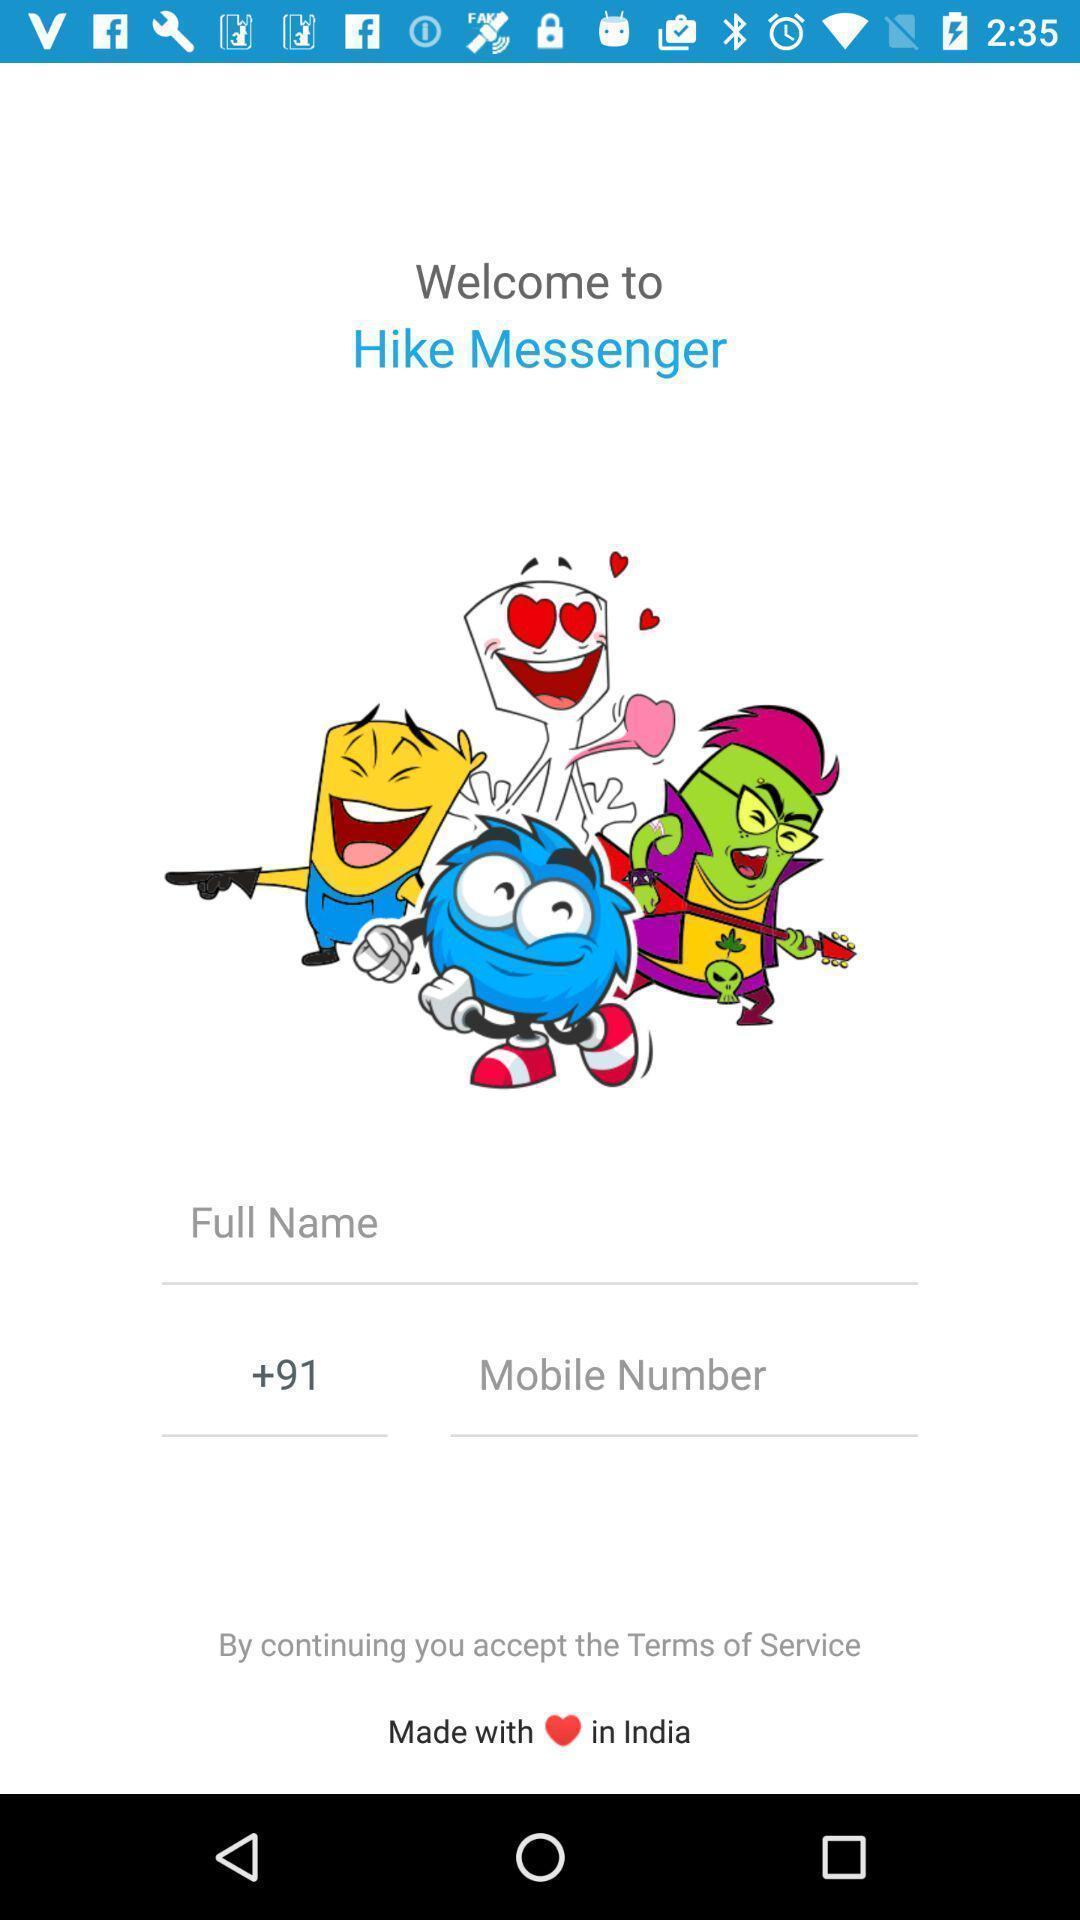Tell me about the visual elements in this screen capture. Welcome page of messaging application. 